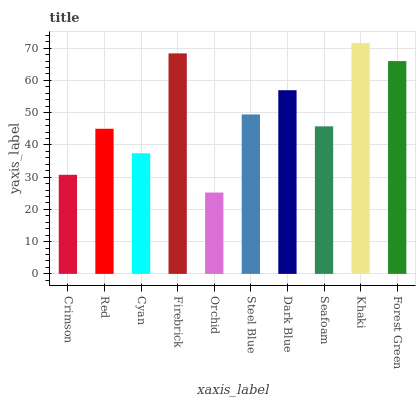Is Orchid the minimum?
Answer yes or no. Yes. Is Khaki the maximum?
Answer yes or no. Yes. Is Red the minimum?
Answer yes or no. No. Is Red the maximum?
Answer yes or no. No. Is Red greater than Crimson?
Answer yes or no. Yes. Is Crimson less than Red?
Answer yes or no. Yes. Is Crimson greater than Red?
Answer yes or no. No. Is Red less than Crimson?
Answer yes or no. No. Is Steel Blue the high median?
Answer yes or no. Yes. Is Seafoam the low median?
Answer yes or no. Yes. Is Red the high median?
Answer yes or no. No. Is Dark Blue the low median?
Answer yes or no. No. 